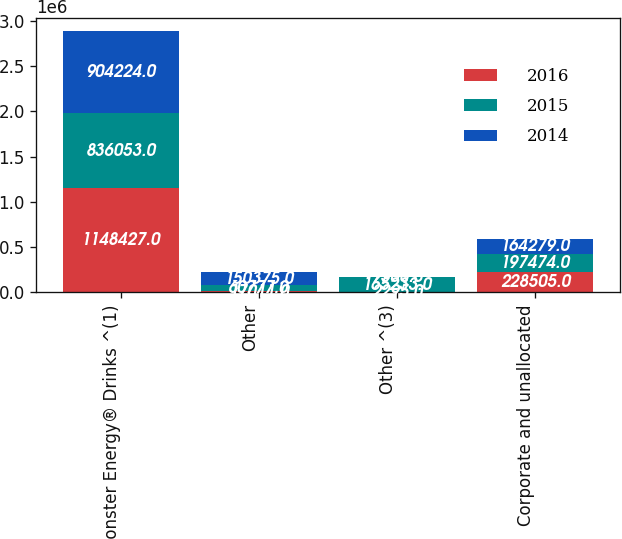<chart> <loc_0><loc_0><loc_500><loc_500><stacked_bar_chart><ecel><fcel>Monster Energy® Drinks ^(1)<fcel>Other<fcel>Other ^(3)<fcel>Corporate and unallocated<nl><fcel>2016<fcel>1.14843e+06<fcel>17011<fcel>2295<fcel>228505<nl><fcel>2015<fcel>836053<fcel>60777<fcel>165233<fcel>197474<nl><fcel>2014<fcel>904224<fcel>150375<fcel>7560<fcel>164279<nl></chart> 